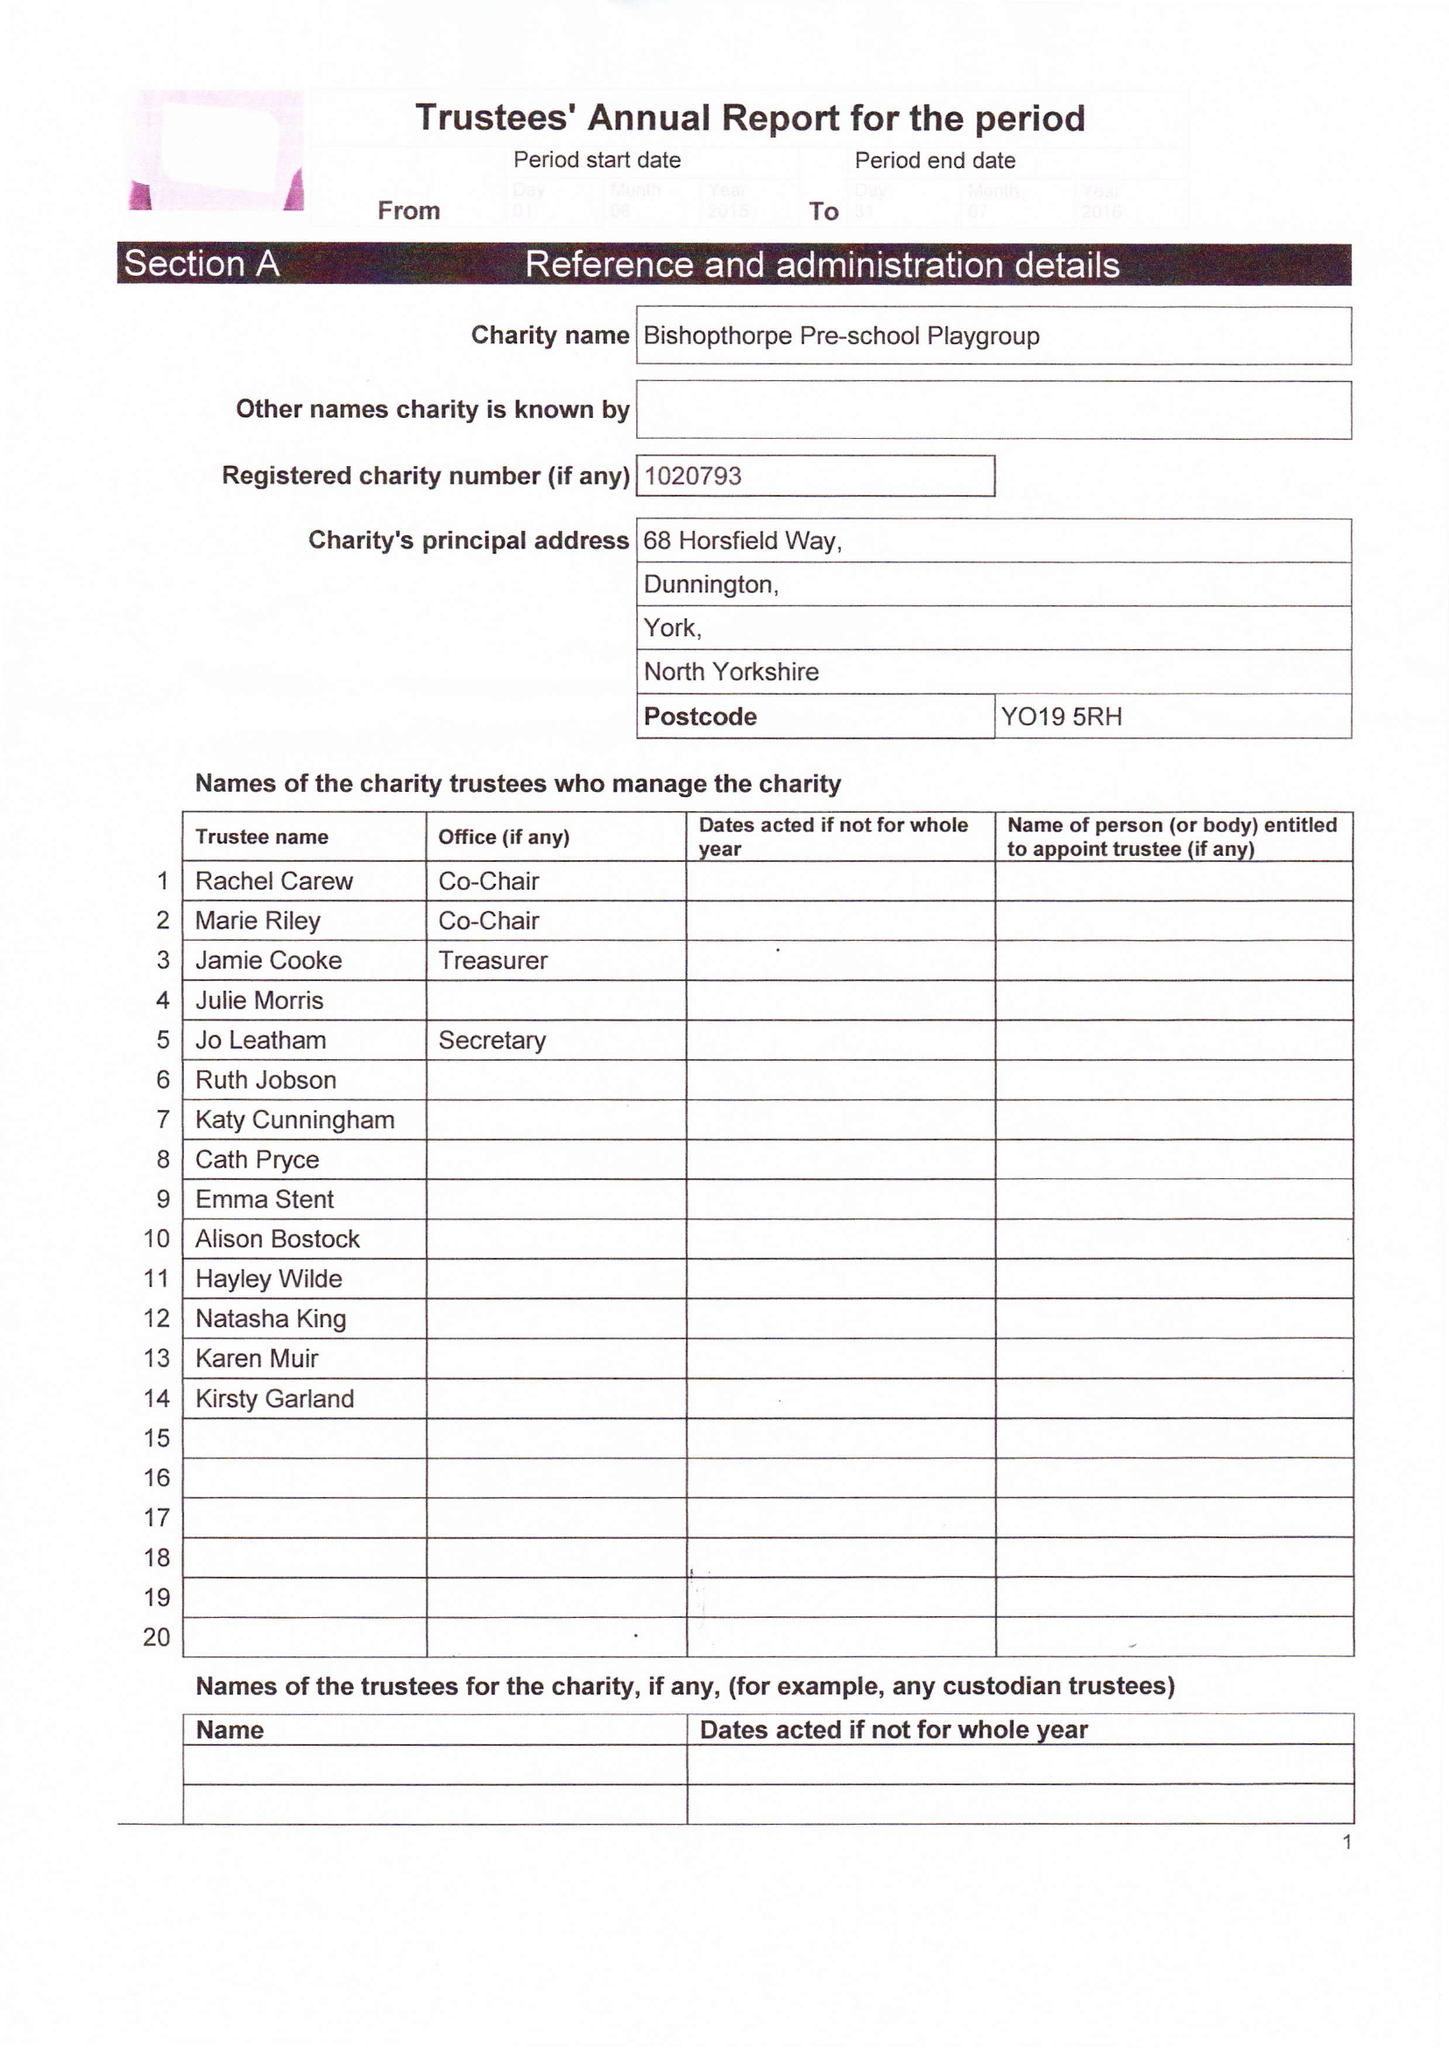What is the value for the spending_annually_in_british_pounds?
Answer the question using a single word or phrase. 73873.00 